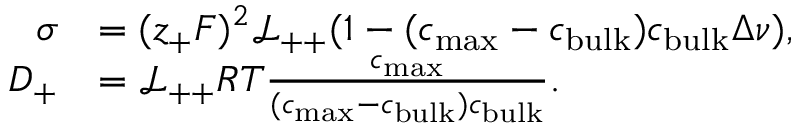<formula> <loc_0><loc_0><loc_500><loc_500>\begin{array} { r l } { \sigma } & { = ( z _ { + } F ) ^ { 2 } \mathcal { L _ { + + } } ( 1 - ( c _ { \max } - c _ { b u l k } ) c _ { b u l k } \Delta \nu ) , } \\ { D _ { + } } & { = \mathcal { L _ { + + } } R T \frac { c _ { \max } } { ( c _ { \max } - c _ { b u l k } ) c _ { b u l k } } . } \end{array}</formula> 